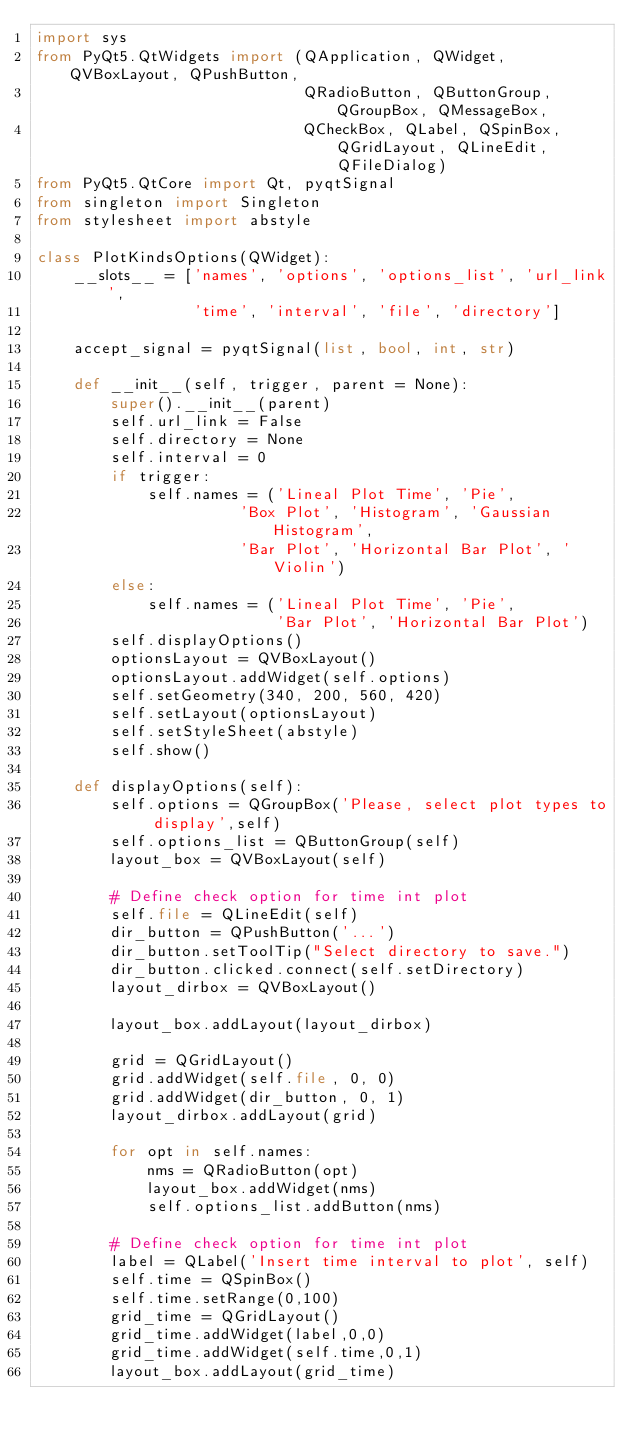Convert code to text. <code><loc_0><loc_0><loc_500><loc_500><_Python_>import sys
from PyQt5.QtWidgets import (QApplication, QWidget, QVBoxLayout, QPushButton,
                             QRadioButton, QButtonGroup, QGroupBox, QMessageBox,
                             QCheckBox, QLabel, QSpinBox, QGridLayout, QLineEdit, QFileDialog)
from PyQt5.QtCore import Qt, pyqtSignal
from singleton import Singleton
from stylesheet import abstyle

class PlotKindsOptions(QWidget):
    __slots__ = ['names', 'options', 'options_list', 'url_link',
                 'time', 'interval', 'file', 'directory']

    accept_signal = pyqtSignal(list, bool, int, str)

    def __init__(self, trigger, parent = None):
        super().__init__(parent)
        self.url_link = False
        self.directory = None
        self.interval = 0
        if trigger:
            self.names = ('Lineal Plot Time', 'Pie',
                      'Box Plot', 'Histogram', 'Gaussian Histogram',
                      'Bar Plot', 'Horizontal Bar Plot', 'Violin')
        else:
            self.names = ('Lineal Plot Time', 'Pie',
                          'Bar Plot', 'Horizontal Bar Plot')
        self.displayOptions()
        optionsLayout = QVBoxLayout()
        optionsLayout.addWidget(self.options)
        self.setGeometry(340, 200, 560, 420)
        self.setLayout(optionsLayout)
        self.setStyleSheet(abstyle)
        self.show()

    def displayOptions(self):
        self.options = QGroupBox('Please, select plot types to display',self)
        self.options_list = QButtonGroup(self)
        layout_box = QVBoxLayout(self)

        # Define check option for time int plot
        self.file = QLineEdit(self)
        dir_button = QPushButton('...')
        dir_button.setToolTip("Select directory to save.")
        dir_button.clicked.connect(self.setDirectory)
        layout_dirbox = QVBoxLayout()

        layout_box.addLayout(layout_dirbox)

        grid = QGridLayout()
        grid.addWidget(self.file, 0, 0)
        grid.addWidget(dir_button, 0, 1)
        layout_dirbox.addLayout(grid)

        for opt in self.names:
            nms = QRadioButton(opt)
            layout_box.addWidget(nms)
            self.options_list.addButton(nms)

        # Define check option for time int plot
        label = QLabel('Insert time interval to plot', self)
        self.time = QSpinBox()
        self.time.setRange(0,100)
        grid_time = QGridLayout()
        grid_time.addWidget(label,0,0)
        grid_time.addWidget(self.time,0,1)
        layout_box.addLayout(grid_time)</code> 